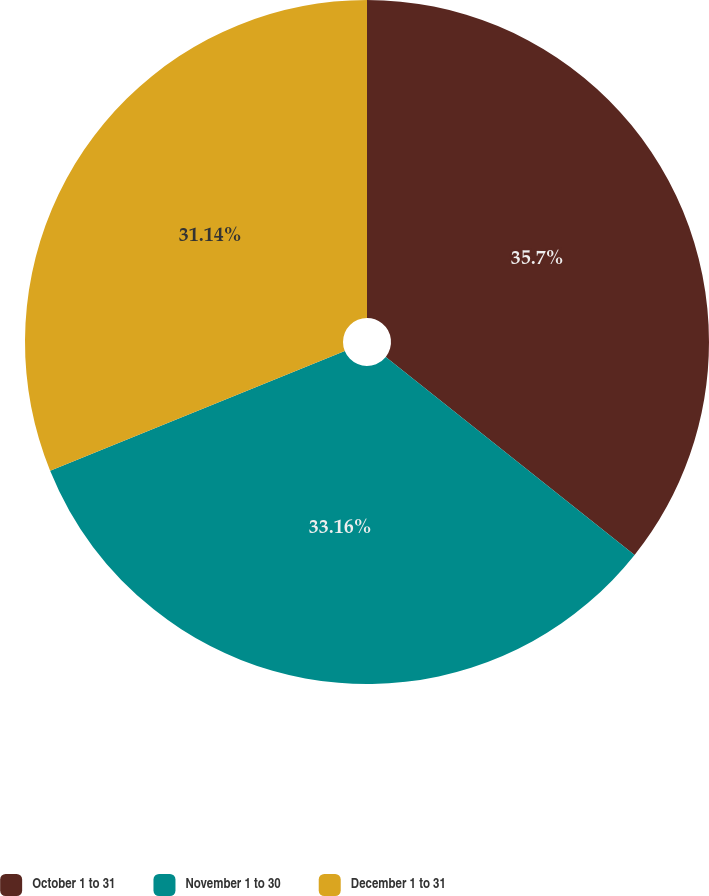Convert chart. <chart><loc_0><loc_0><loc_500><loc_500><pie_chart><fcel>October 1 to 31<fcel>November 1 to 30<fcel>December 1 to 31<nl><fcel>35.7%<fcel>33.16%<fcel>31.14%<nl></chart> 